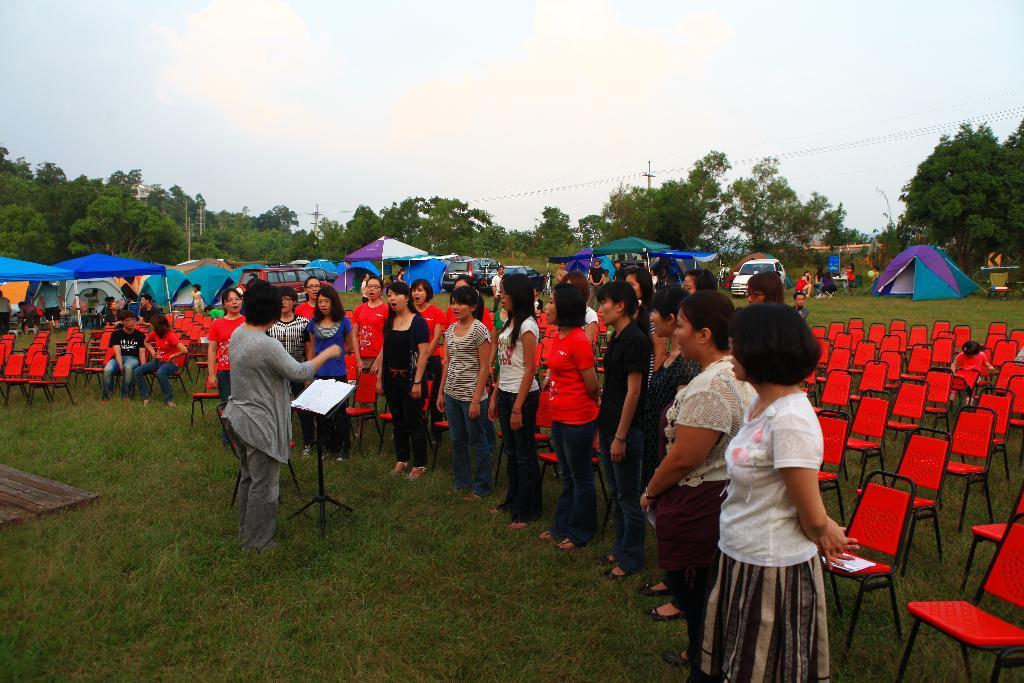How would you summarize this image in a sentence or two? This is an outside view. At the bottom, I can see the grass. Here I can see many people are standing facing towards the left side. In front of these people there is a person standing. In front of her there is a metal stand. On the right side there are many empty chairs. In the background there are few tents, vehicles and trees. At the top of the image I can see the sky. 